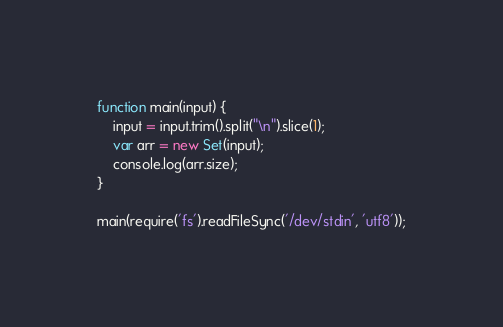<code> <loc_0><loc_0><loc_500><loc_500><_JavaScript_>function main(input) {
    input = input.trim().split("\n").slice(1);
    var arr = new Set(input);
    console.log(arr.size);
}

main(require('fs').readFileSync('/dev/stdin', 'utf8'));</code> 